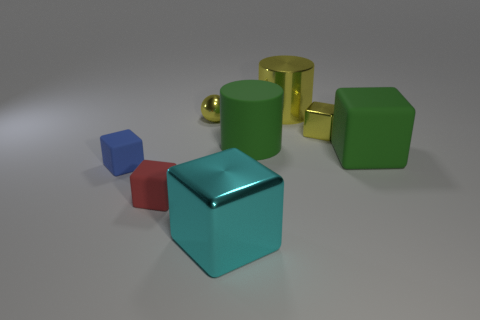What number of cylinders are either small yellow objects or small cyan rubber objects? 0 